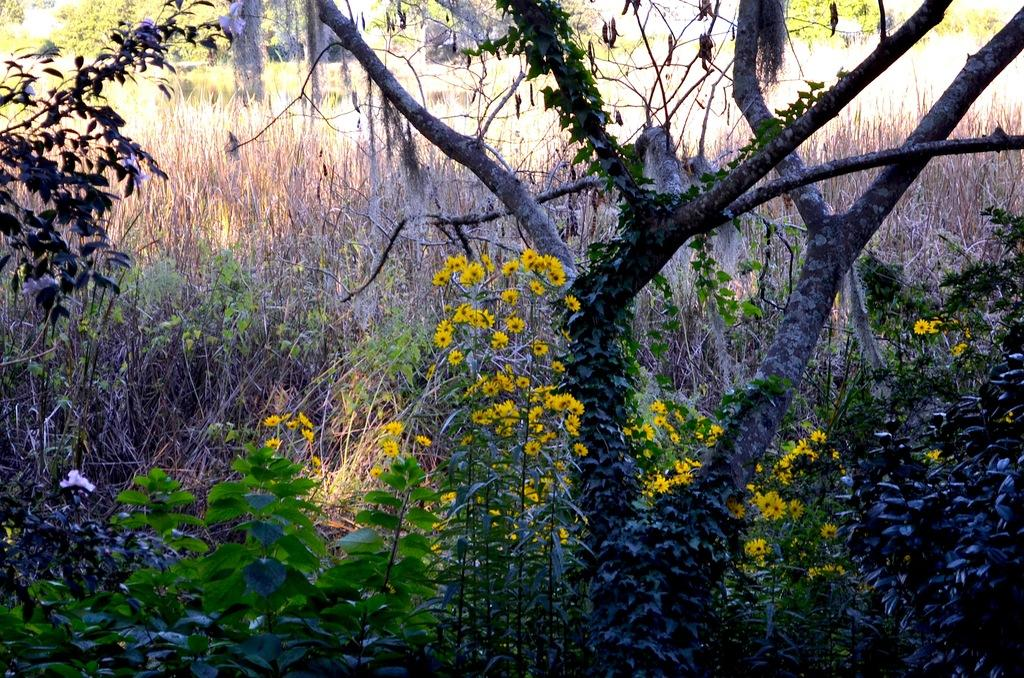What type of vegetation can be seen in the image? There is grass, plants, and trees in the image. Are there any flowers visible in the image? Yes, flowers are present on the plants in the image. What reason does the grass give for growing in the image? The grass does not give a reason for growing in the image; it simply exists as part of the natural environment. 